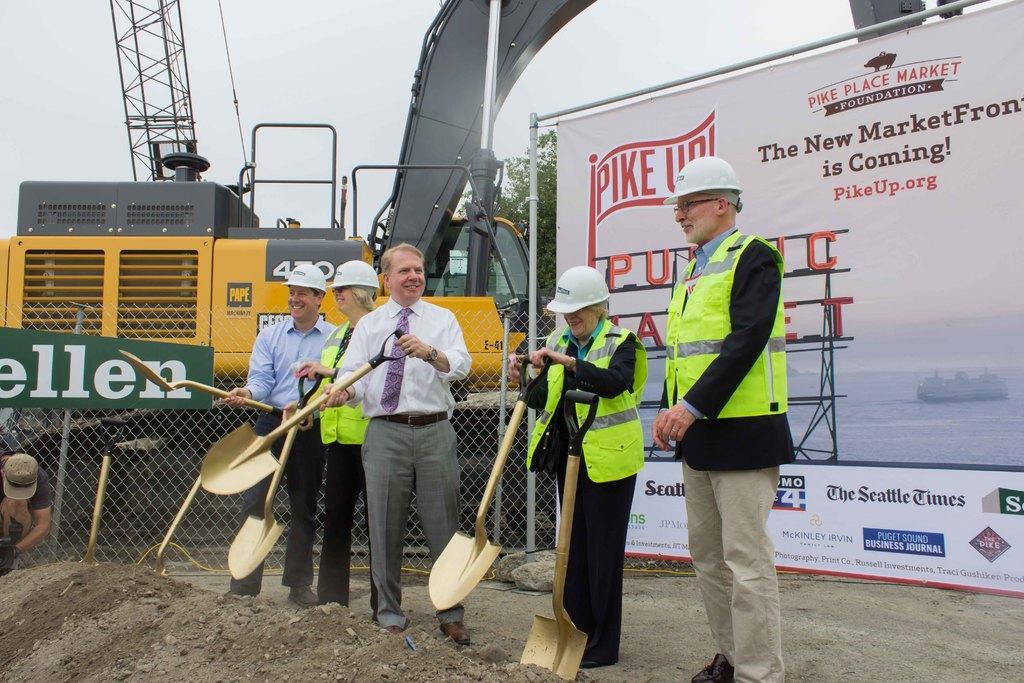Can you describe this image briefly? In this image we can see one man standing, some people wearing helmets, one crane, two shovels on the ground, some mud, some wires, one green board with text attached to the pole, one fence, one tree, one man in crouch position holding one object, some people standing and holding shovels. There is one big white banner with text and images attached to the poles. At the top there is the sky. 